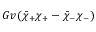<formula> <loc_0><loc_0><loc_500><loc_500>G v ( \bar { \chi } _ { + } \chi _ { + } - \bar { \chi } _ { - } \chi _ { - } )</formula> 